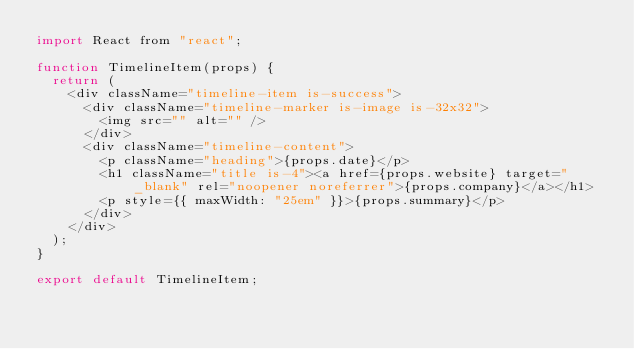<code> <loc_0><loc_0><loc_500><loc_500><_JavaScript_>import React from "react";

function TimelineItem(props) {
  return (
    <div className="timeline-item is-success">
      <div className="timeline-marker is-image is-32x32">
        <img src="" alt="" />
      </div>
      <div className="timeline-content">
        <p className="heading">{props.date}</p>
        <h1 className="title is-4"><a href={props.website} target="_blank" rel="noopener noreferrer">{props.company}</a></h1>
        <p style={{ maxWidth: "25em" }}>{props.summary}</p>
      </div>
    </div>
  );
}

export default TimelineItem;
</code> 